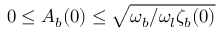Convert formula to latex. <formula><loc_0><loc_0><loc_500><loc_500>0 \leq A _ { b } ( 0 ) \leq \sqrt { \omega _ { b } / \omega _ { l } \zeta _ { b } ( 0 ) }</formula> 